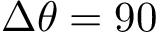<formula> <loc_0><loc_0><loc_500><loc_500>\Delta \theta = 9 0</formula> 